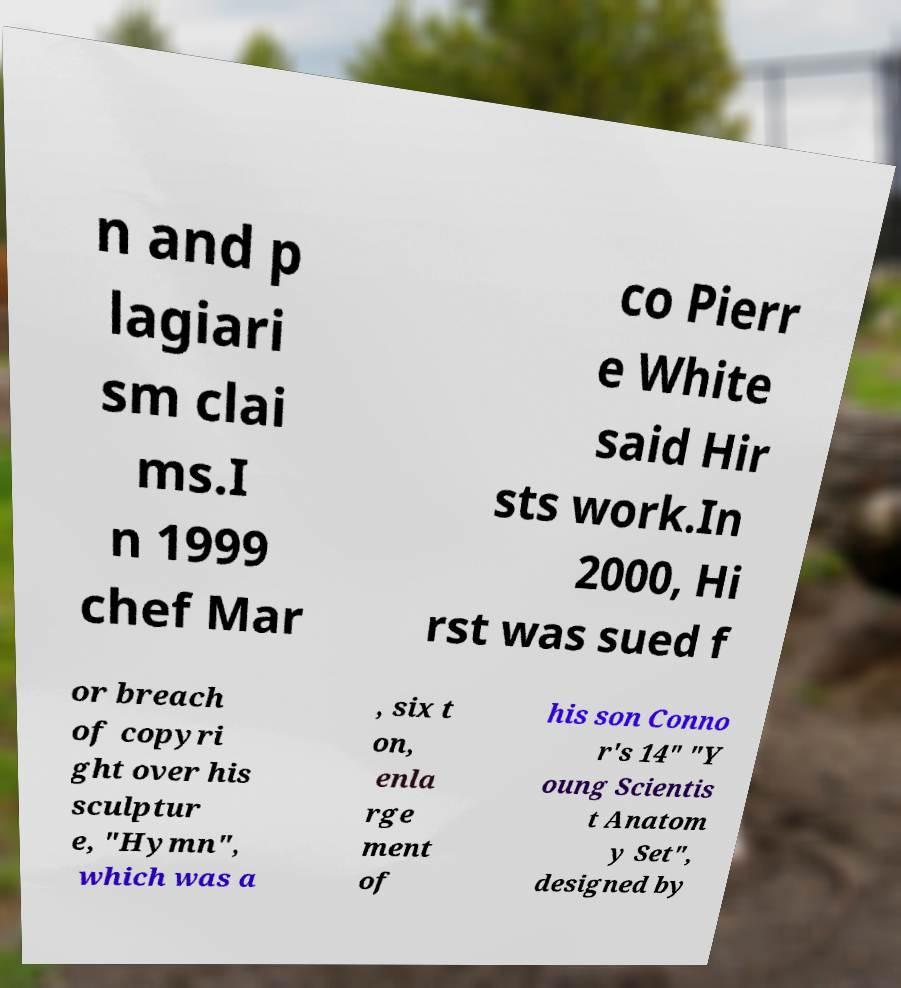For documentation purposes, I need the text within this image transcribed. Could you provide that? n and p lagiari sm clai ms.I n 1999 chef Mar co Pierr e White said Hir sts work.In 2000, Hi rst was sued f or breach of copyri ght over his sculptur e, "Hymn", which was a , six t on, enla rge ment of his son Conno r's 14" "Y oung Scientis t Anatom y Set", designed by 